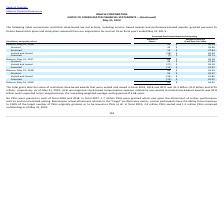According to Oracle Corporation's financial document, How many PSUs were granted in fiscal 2019? No PSUs were granted in each of fiscal 2019 and 2018.. The document states: "No PSUs were granted in each of fiscal 2019 and 2018. In fiscal 2017, 1.7 million PSUs were granted which vest upon the attainment of certain performa..." Also, How many PSUs remained outstanding as of May 31, 2019? In fiscal 2019, 2.4 million PSUs vested and 1.3 million PSUs remained outstanding as of May 31, 2019.. The document states: "riginally granted, or to be issued no PSUs at all. In fiscal 2019, 2.4 million PSUs vested and 1.3 million PSUs remained outstanding as of May 31, 201..." Also, When does the company's fiscal year end? According to the financial document, May 31. The relevant text states: "May 31, 2019..." Also, can you calculate: How many shares were granted over the 3 year period from 2017 to 2019 ? Based on the calculation: (42+44+53), the result is 139 (in millions). This is based on the information: "Granted 53 $ 42.47 Granted 42 $ 39.40 Granted 44 $ 47.42..." The key data points involved are: 42, 44, 53. Also, can you calculate: What is the average total grant date fair value of restricted stock-based awards that were vested and issued in fiscal 2019, 2018 and 2017, in millions? To answer this question, I need to perform calculations using the financial data. The calculation is: (($1.3 billion +$1.0 billion +$715 million)/3), which equals 1005 (in millions). This is based on the information: "in fiscal 2019, 2018 and 2017 was $1.3 billion, $1.0 billion and $715 million, respectively. As of May 31, 2019, total unrecognized stock-based compensa ted and issued in fiscal 2019, 2018 and 2017 wa..." The key data points involved are: 1.0, 1.3, 3. Also, can you calculate: What is the total grant date fair value of restricted stock-based awards that were granted in fiscal 2019? Based on the calculation: 53*42.47, the result is 2250.91 (in millions). This is based on the information: "Granted 53 $ 42.47 Granted 53 $ 42.47..." The key data points involved are: 42.47, 53. 